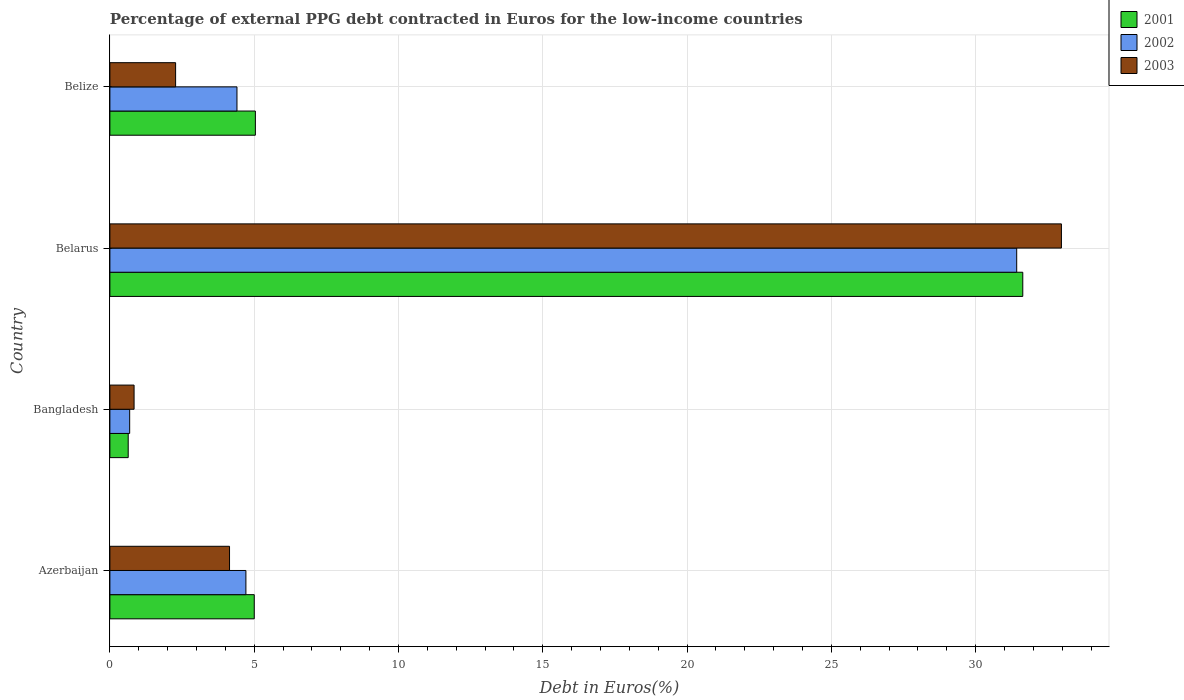How many different coloured bars are there?
Your answer should be compact. 3. Are the number of bars on each tick of the Y-axis equal?
Your answer should be compact. Yes. What is the label of the 3rd group of bars from the top?
Your answer should be very brief. Bangladesh. What is the percentage of external PPG debt contracted in Euros in 2002 in Bangladesh?
Your answer should be compact. 0.69. Across all countries, what is the maximum percentage of external PPG debt contracted in Euros in 2001?
Your answer should be compact. 31.63. Across all countries, what is the minimum percentage of external PPG debt contracted in Euros in 2003?
Your answer should be compact. 0.84. In which country was the percentage of external PPG debt contracted in Euros in 2001 maximum?
Provide a short and direct response. Belarus. In which country was the percentage of external PPG debt contracted in Euros in 2002 minimum?
Provide a short and direct response. Bangladesh. What is the total percentage of external PPG debt contracted in Euros in 2002 in the graph?
Keep it short and to the point. 41.22. What is the difference between the percentage of external PPG debt contracted in Euros in 2001 in Azerbaijan and that in Belize?
Keep it short and to the point. -0.04. What is the difference between the percentage of external PPG debt contracted in Euros in 2003 in Belize and the percentage of external PPG debt contracted in Euros in 2001 in Belarus?
Ensure brevity in your answer.  -29.36. What is the average percentage of external PPG debt contracted in Euros in 2003 per country?
Provide a succinct answer. 10.06. What is the difference between the percentage of external PPG debt contracted in Euros in 2003 and percentage of external PPG debt contracted in Euros in 2002 in Belize?
Your response must be concise. -2.13. What is the ratio of the percentage of external PPG debt contracted in Euros in 2001 in Azerbaijan to that in Belize?
Your response must be concise. 0.99. Is the percentage of external PPG debt contracted in Euros in 2002 in Azerbaijan less than that in Bangladesh?
Make the answer very short. No. What is the difference between the highest and the second highest percentage of external PPG debt contracted in Euros in 2002?
Provide a short and direct response. 26.71. What is the difference between the highest and the lowest percentage of external PPG debt contracted in Euros in 2002?
Offer a terse response. 30.74. What does the 2nd bar from the top in Belarus represents?
Make the answer very short. 2002. Is it the case that in every country, the sum of the percentage of external PPG debt contracted in Euros in 2003 and percentage of external PPG debt contracted in Euros in 2001 is greater than the percentage of external PPG debt contracted in Euros in 2002?
Provide a short and direct response. Yes. Are all the bars in the graph horizontal?
Offer a very short reply. Yes. How many countries are there in the graph?
Make the answer very short. 4. Does the graph contain any zero values?
Provide a succinct answer. No. Does the graph contain grids?
Offer a very short reply. Yes. Where does the legend appear in the graph?
Your answer should be very brief. Top right. How are the legend labels stacked?
Ensure brevity in your answer.  Vertical. What is the title of the graph?
Offer a very short reply. Percentage of external PPG debt contracted in Euros for the low-income countries. What is the label or title of the X-axis?
Offer a terse response. Debt in Euros(%). What is the Debt in Euros(%) in 2001 in Azerbaijan?
Keep it short and to the point. 5. What is the Debt in Euros(%) of 2002 in Azerbaijan?
Offer a very short reply. 4.71. What is the Debt in Euros(%) in 2003 in Azerbaijan?
Offer a terse response. 4.15. What is the Debt in Euros(%) of 2001 in Bangladesh?
Your answer should be very brief. 0.63. What is the Debt in Euros(%) of 2002 in Bangladesh?
Provide a succinct answer. 0.69. What is the Debt in Euros(%) of 2003 in Bangladesh?
Your answer should be compact. 0.84. What is the Debt in Euros(%) of 2001 in Belarus?
Your answer should be compact. 31.63. What is the Debt in Euros(%) in 2002 in Belarus?
Give a very brief answer. 31.42. What is the Debt in Euros(%) in 2003 in Belarus?
Offer a very short reply. 32.97. What is the Debt in Euros(%) in 2001 in Belize?
Make the answer very short. 5.04. What is the Debt in Euros(%) of 2002 in Belize?
Ensure brevity in your answer.  4.4. What is the Debt in Euros(%) of 2003 in Belize?
Keep it short and to the point. 2.28. Across all countries, what is the maximum Debt in Euros(%) in 2001?
Give a very brief answer. 31.63. Across all countries, what is the maximum Debt in Euros(%) in 2002?
Your response must be concise. 31.42. Across all countries, what is the maximum Debt in Euros(%) of 2003?
Offer a terse response. 32.97. Across all countries, what is the minimum Debt in Euros(%) of 2001?
Your answer should be very brief. 0.63. Across all countries, what is the minimum Debt in Euros(%) of 2002?
Your answer should be compact. 0.69. Across all countries, what is the minimum Debt in Euros(%) in 2003?
Make the answer very short. 0.84. What is the total Debt in Euros(%) in 2001 in the graph?
Your answer should be very brief. 42.31. What is the total Debt in Euros(%) of 2002 in the graph?
Your answer should be compact. 41.22. What is the total Debt in Euros(%) of 2003 in the graph?
Your response must be concise. 40.23. What is the difference between the Debt in Euros(%) in 2001 in Azerbaijan and that in Bangladesh?
Provide a short and direct response. 4.37. What is the difference between the Debt in Euros(%) in 2002 in Azerbaijan and that in Bangladesh?
Your response must be concise. 4.03. What is the difference between the Debt in Euros(%) in 2003 in Azerbaijan and that in Bangladesh?
Your answer should be very brief. 3.31. What is the difference between the Debt in Euros(%) in 2001 in Azerbaijan and that in Belarus?
Provide a short and direct response. -26.63. What is the difference between the Debt in Euros(%) of 2002 in Azerbaijan and that in Belarus?
Make the answer very short. -26.71. What is the difference between the Debt in Euros(%) in 2003 in Azerbaijan and that in Belarus?
Make the answer very short. -28.83. What is the difference between the Debt in Euros(%) in 2001 in Azerbaijan and that in Belize?
Your answer should be very brief. -0.04. What is the difference between the Debt in Euros(%) in 2002 in Azerbaijan and that in Belize?
Ensure brevity in your answer.  0.31. What is the difference between the Debt in Euros(%) in 2003 in Azerbaijan and that in Belize?
Provide a short and direct response. 1.87. What is the difference between the Debt in Euros(%) of 2001 in Bangladesh and that in Belarus?
Your response must be concise. -31. What is the difference between the Debt in Euros(%) in 2002 in Bangladesh and that in Belarus?
Provide a succinct answer. -30.74. What is the difference between the Debt in Euros(%) of 2003 in Bangladesh and that in Belarus?
Ensure brevity in your answer.  -32.13. What is the difference between the Debt in Euros(%) in 2001 in Bangladesh and that in Belize?
Provide a succinct answer. -4.41. What is the difference between the Debt in Euros(%) in 2002 in Bangladesh and that in Belize?
Provide a succinct answer. -3.72. What is the difference between the Debt in Euros(%) in 2003 in Bangladesh and that in Belize?
Keep it short and to the point. -1.44. What is the difference between the Debt in Euros(%) of 2001 in Belarus and that in Belize?
Keep it short and to the point. 26.59. What is the difference between the Debt in Euros(%) in 2002 in Belarus and that in Belize?
Your answer should be compact. 27.02. What is the difference between the Debt in Euros(%) in 2003 in Belarus and that in Belize?
Keep it short and to the point. 30.69. What is the difference between the Debt in Euros(%) in 2001 in Azerbaijan and the Debt in Euros(%) in 2002 in Bangladesh?
Provide a succinct answer. 4.32. What is the difference between the Debt in Euros(%) of 2001 in Azerbaijan and the Debt in Euros(%) of 2003 in Bangladesh?
Ensure brevity in your answer.  4.16. What is the difference between the Debt in Euros(%) of 2002 in Azerbaijan and the Debt in Euros(%) of 2003 in Bangladesh?
Your answer should be very brief. 3.88. What is the difference between the Debt in Euros(%) in 2001 in Azerbaijan and the Debt in Euros(%) in 2002 in Belarus?
Your answer should be compact. -26.42. What is the difference between the Debt in Euros(%) in 2001 in Azerbaijan and the Debt in Euros(%) in 2003 in Belarus?
Keep it short and to the point. -27.97. What is the difference between the Debt in Euros(%) in 2002 in Azerbaijan and the Debt in Euros(%) in 2003 in Belarus?
Keep it short and to the point. -28.26. What is the difference between the Debt in Euros(%) of 2001 in Azerbaijan and the Debt in Euros(%) of 2002 in Belize?
Ensure brevity in your answer.  0.6. What is the difference between the Debt in Euros(%) in 2001 in Azerbaijan and the Debt in Euros(%) in 2003 in Belize?
Keep it short and to the point. 2.73. What is the difference between the Debt in Euros(%) of 2002 in Azerbaijan and the Debt in Euros(%) of 2003 in Belize?
Keep it short and to the point. 2.44. What is the difference between the Debt in Euros(%) of 2001 in Bangladesh and the Debt in Euros(%) of 2002 in Belarus?
Keep it short and to the point. -30.79. What is the difference between the Debt in Euros(%) of 2001 in Bangladesh and the Debt in Euros(%) of 2003 in Belarus?
Offer a very short reply. -32.34. What is the difference between the Debt in Euros(%) of 2002 in Bangladesh and the Debt in Euros(%) of 2003 in Belarus?
Keep it short and to the point. -32.29. What is the difference between the Debt in Euros(%) of 2001 in Bangladesh and the Debt in Euros(%) of 2002 in Belize?
Your response must be concise. -3.77. What is the difference between the Debt in Euros(%) in 2001 in Bangladesh and the Debt in Euros(%) in 2003 in Belize?
Provide a short and direct response. -1.64. What is the difference between the Debt in Euros(%) in 2002 in Bangladesh and the Debt in Euros(%) in 2003 in Belize?
Ensure brevity in your answer.  -1.59. What is the difference between the Debt in Euros(%) in 2001 in Belarus and the Debt in Euros(%) in 2002 in Belize?
Provide a short and direct response. 27.23. What is the difference between the Debt in Euros(%) in 2001 in Belarus and the Debt in Euros(%) in 2003 in Belize?
Keep it short and to the point. 29.36. What is the difference between the Debt in Euros(%) in 2002 in Belarus and the Debt in Euros(%) in 2003 in Belize?
Keep it short and to the point. 29.15. What is the average Debt in Euros(%) of 2001 per country?
Offer a terse response. 10.58. What is the average Debt in Euros(%) of 2002 per country?
Provide a short and direct response. 10.31. What is the average Debt in Euros(%) in 2003 per country?
Offer a terse response. 10.06. What is the difference between the Debt in Euros(%) of 2001 and Debt in Euros(%) of 2002 in Azerbaijan?
Offer a terse response. 0.29. What is the difference between the Debt in Euros(%) in 2001 and Debt in Euros(%) in 2003 in Azerbaijan?
Provide a succinct answer. 0.86. What is the difference between the Debt in Euros(%) in 2002 and Debt in Euros(%) in 2003 in Azerbaijan?
Offer a terse response. 0.57. What is the difference between the Debt in Euros(%) in 2001 and Debt in Euros(%) in 2002 in Bangladesh?
Make the answer very short. -0.05. What is the difference between the Debt in Euros(%) in 2001 and Debt in Euros(%) in 2003 in Bangladesh?
Keep it short and to the point. -0.2. What is the difference between the Debt in Euros(%) of 2002 and Debt in Euros(%) of 2003 in Bangladesh?
Your answer should be very brief. -0.15. What is the difference between the Debt in Euros(%) of 2001 and Debt in Euros(%) of 2002 in Belarus?
Keep it short and to the point. 0.21. What is the difference between the Debt in Euros(%) of 2001 and Debt in Euros(%) of 2003 in Belarus?
Make the answer very short. -1.34. What is the difference between the Debt in Euros(%) of 2002 and Debt in Euros(%) of 2003 in Belarus?
Your response must be concise. -1.55. What is the difference between the Debt in Euros(%) of 2001 and Debt in Euros(%) of 2002 in Belize?
Offer a terse response. 0.64. What is the difference between the Debt in Euros(%) in 2001 and Debt in Euros(%) in 2003 in Belize?
Ensure brevity in your answer.  2.76. What is the difference between the Debt in Euros(%) in 2002 and Debt in Euros(%) in 2003 in Belize?
Offer a terse response. 2.13. What is the ratio of the Debt in Euros(%) of 2001 in Azerbaijan to that in Bangladesh?
Give a very brief answer. 7.88. What is the ratio of the Debt in Euros(%) of 2002 in Azerbaijan to that in Bangladesh?
Provide a short and direct response. 6.88. What is the ratio of the Debt in Euros(%) in 2003 in Azerbaijan to that in Bangladesh?
Your response must be concise. 4.95. What is the ratio of the Debt in Euros(%) in 2001 in Azerbaijan to that in Belarus?
Provide a succinct answer. 0.16. What is the ratio of the Debt in Euros(%) of 2002 in Azerbaijan to that in Belarus?
Offer a terse response. 0.15. What is the ratio of the Debt in Euros(%) in 2003 in Azerbaijan to that in Belarus?
Keep it short and to the point. 0.13. What is the ratio of the Debt in Euros(%) in 2001 in Azerbaijan to that in Belize?
Keep it short and to the point. 0.99. What is the ratio of the Debt in Euros(%) of 2002 in Azerbaijan to that in Belize?
Your answer should be very brief. 1.07. What is the ratio of the Debt in Euros(%) in 2003 in Azerbaijan to that in Belize?
Provide a succinct answer. 1.82. What is the ratio of the Debt in Euros(%) of 2001 in Bangladesh to that in Belarus?
Make the answer very short. 0.02. What is the ratio of the Debt in Euros(%) in 2002 in Bangladesh to that in Belarus?
Keep it short and to the point. 0.02. What is the ratio of the Debt in Euros(%) of 2003 in Bangladesh to that in Belarus?
Your answer should be compact. 0.03. What is the ratio of the Debt in Euros(%) of 2001 in Bangladesh to that in Belize?
Your answer should be very brief. 0.13. What is the ratio of the Debt in Euros(%) of 2002 in Bangladesh to that in Belize?
Give a very brief answer. 0.16. What is the ratio of the Debt in Euros(%) of 2003 in Bangladesh to that in Belize?
Your answer should be very brief. 0.37. What is the ratio of the Debt in Euros(%) of 2001 in Belarus to that in Belize?
Provide a short and direct response. 6.27. What is the ratio of the Debt in Euros(%) in 2002 in Belarus to that in Belize?
Keep it short and to the point. 7.14. What is the ratio of the Debt in Euros(%) in 2003 in Belarus to that in Belize?
Keep it short and to the point. 14.48. What is the difference between the highest and the second highest Debt in Euros(%) of 2001?
Ensure brevity in your answer.  26.59. What is the difference between the highest and the second highest Debt in Euros(%) in 2002?
Give a very brief answer. 26.71. What is the difference between the highest and the second highest Debt in Euros(%) in 2003?
Ensure brevity in your answer.  28.83. What is the difference between the highest and the lowest Debt in Euros(%) in 2001?
Offer a very short reply. 31. What is the difference between the highest and the lowest Debt in Euros(%) of 2002?
Your response must be concise. 30.74. What is the difference between the highest and the lowest Debt in Euros(%) in 2003?
Your response must be concise. 32.13. 